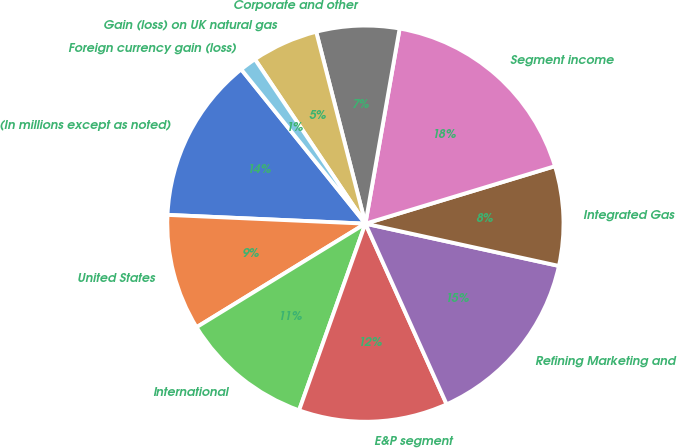Convert chart. <chart><loc_0><loc_0><loc_500><loc_500><pie_chart><fcel>(In millions except as noted)<fcel>United States<fcel>International<fcel>E&P segment<fcel>Refining Marketing and<fcel>Integrated Gas<fcel>Segment income<fcel>Corporate and other<fcel>Gain (loss) on UK natural gas<fcel>Foreign currency gain (loss)<nl><fcel>13.51%<fcel>9.46%<fcel>10.81%<fcel>12.16%<fcel>14.85%<fcel>8.11%<fcel>17.55%<fcel>6.76%<fcel>5.42%<fcel>1.37%<nl></chart> 